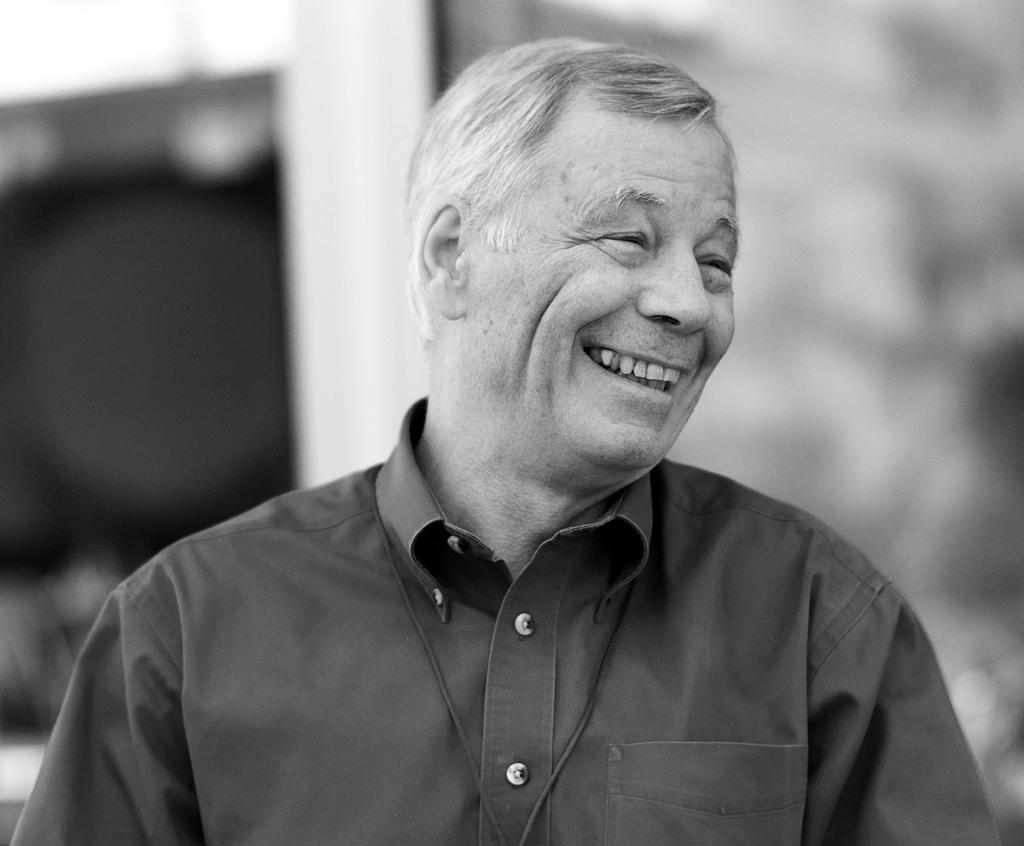What is the color scheme of the image? The image is black and white. Can you describe the person in the image? There is a man in the image. What expression does the man have? The man is smiling. What type of cherry is being served for breakfast in the image? There is no cherry or breakfast present in the image; it is a black and white image of a man smiling. 